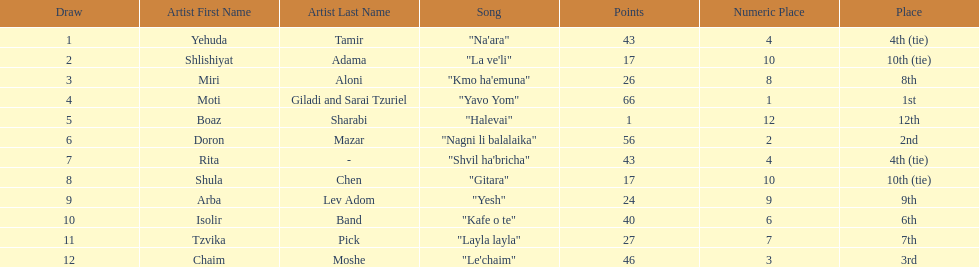What are the points? 43, 17, 26, 66, 1, 56, 43, 17, 24, 40, 27, 46. What is the least? 1. Which artist has that much Boaz Sharabi. 